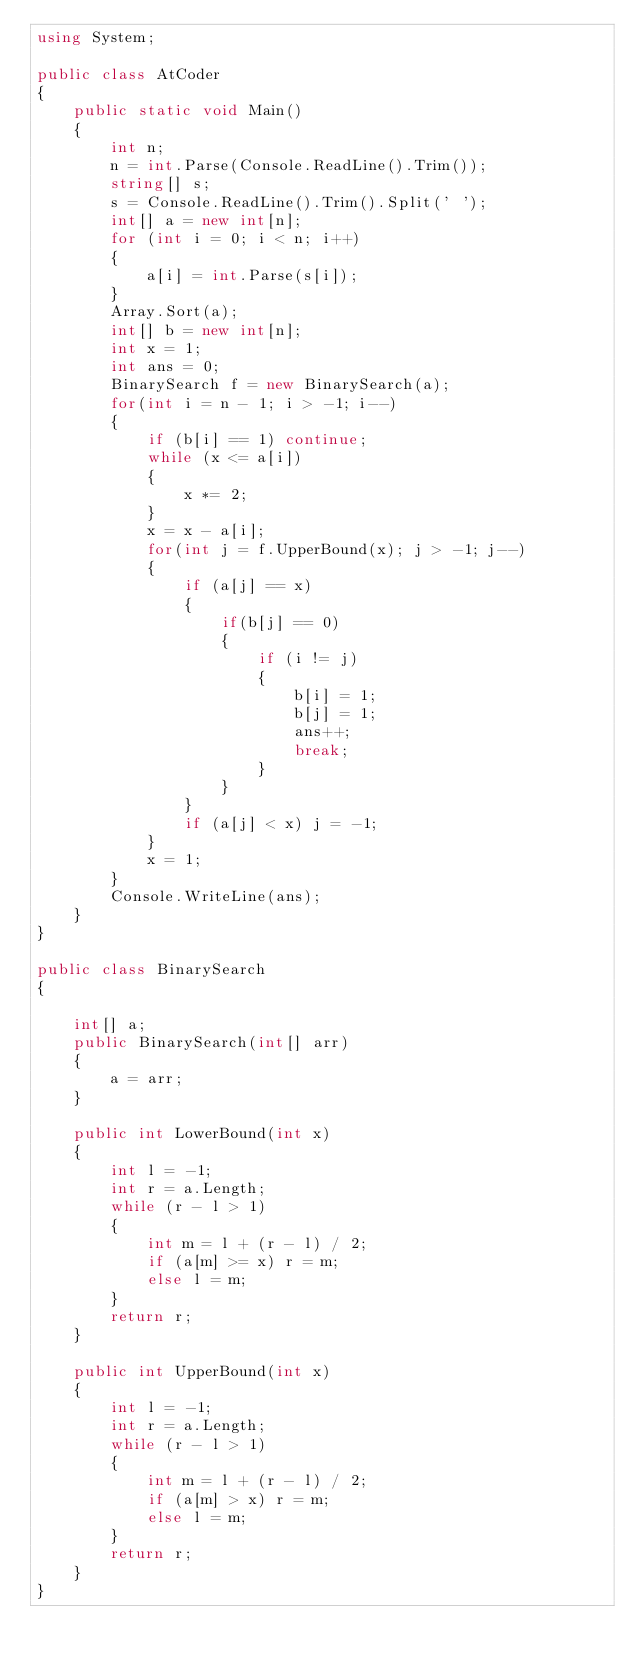Convert code to text. <code><loc_0><loc_0><loc_500><loc_500><_C#_>using System;

public class AtCoder
{
    public static void Main()
    {
        int n;
        n = int.Parse(Console.ReadLine().Trim());
        string[] s;
        s = Console.ReadLine().Trim().Split(' ');
        int[] a = new int[n];
        for (int i = 0; i < n; i++)
        {
            a[i] = int.Parse(s[i]);
        }
        Array.Sort(a);
        int[] b = new int[n];
        int x = 1;
        int ans = 0;
        BinarySearch f = new BinarySearch(a);
        for(int i = n - 1; i > -1; i--)
        {
            if (b[i] == 1) continue;
            while (x <= a[i])
            {
                x *= 2;
            }
            x = x - a[i];
            for(int j = f.UpperBound(x); j > -1; j--)
            {                
                if (a[j] == x)
                {
                    if(b[j] == 0)
                    {
                        if (i != j)
                        {
                            b[i] = 1;
                            b[j] = 1;
                            ans++;
                            break;
                        }                       
                    }
                }
                if (a[j] < x) j = -1;
            }
            x = 1;
        }
        Console.WriteLine(ans);
    }
}

public class BinarySearch
{

    int[] a;
    public BinarySearch(int[] arr)
    {
        a = arr;
    }

    public int LowerBound(int x)
    {
        int l = -1;
        int r = a.Length;
        while (r - l > 1)
        {
            int m = l + (r - l) / 2;
            if (a[m] >= x) r = m;
            else l = m;
        }
        return r;
    }

    public int UpperBound(int x)
    {
        int l = -1;
        int r = a.Length;
        while (r - l > 1)
        {
            int m = l + (r - l) / 2;
            if (a[m] > x) r = m;
            else l = m;
        }
        return r;
    }
}
</code> 